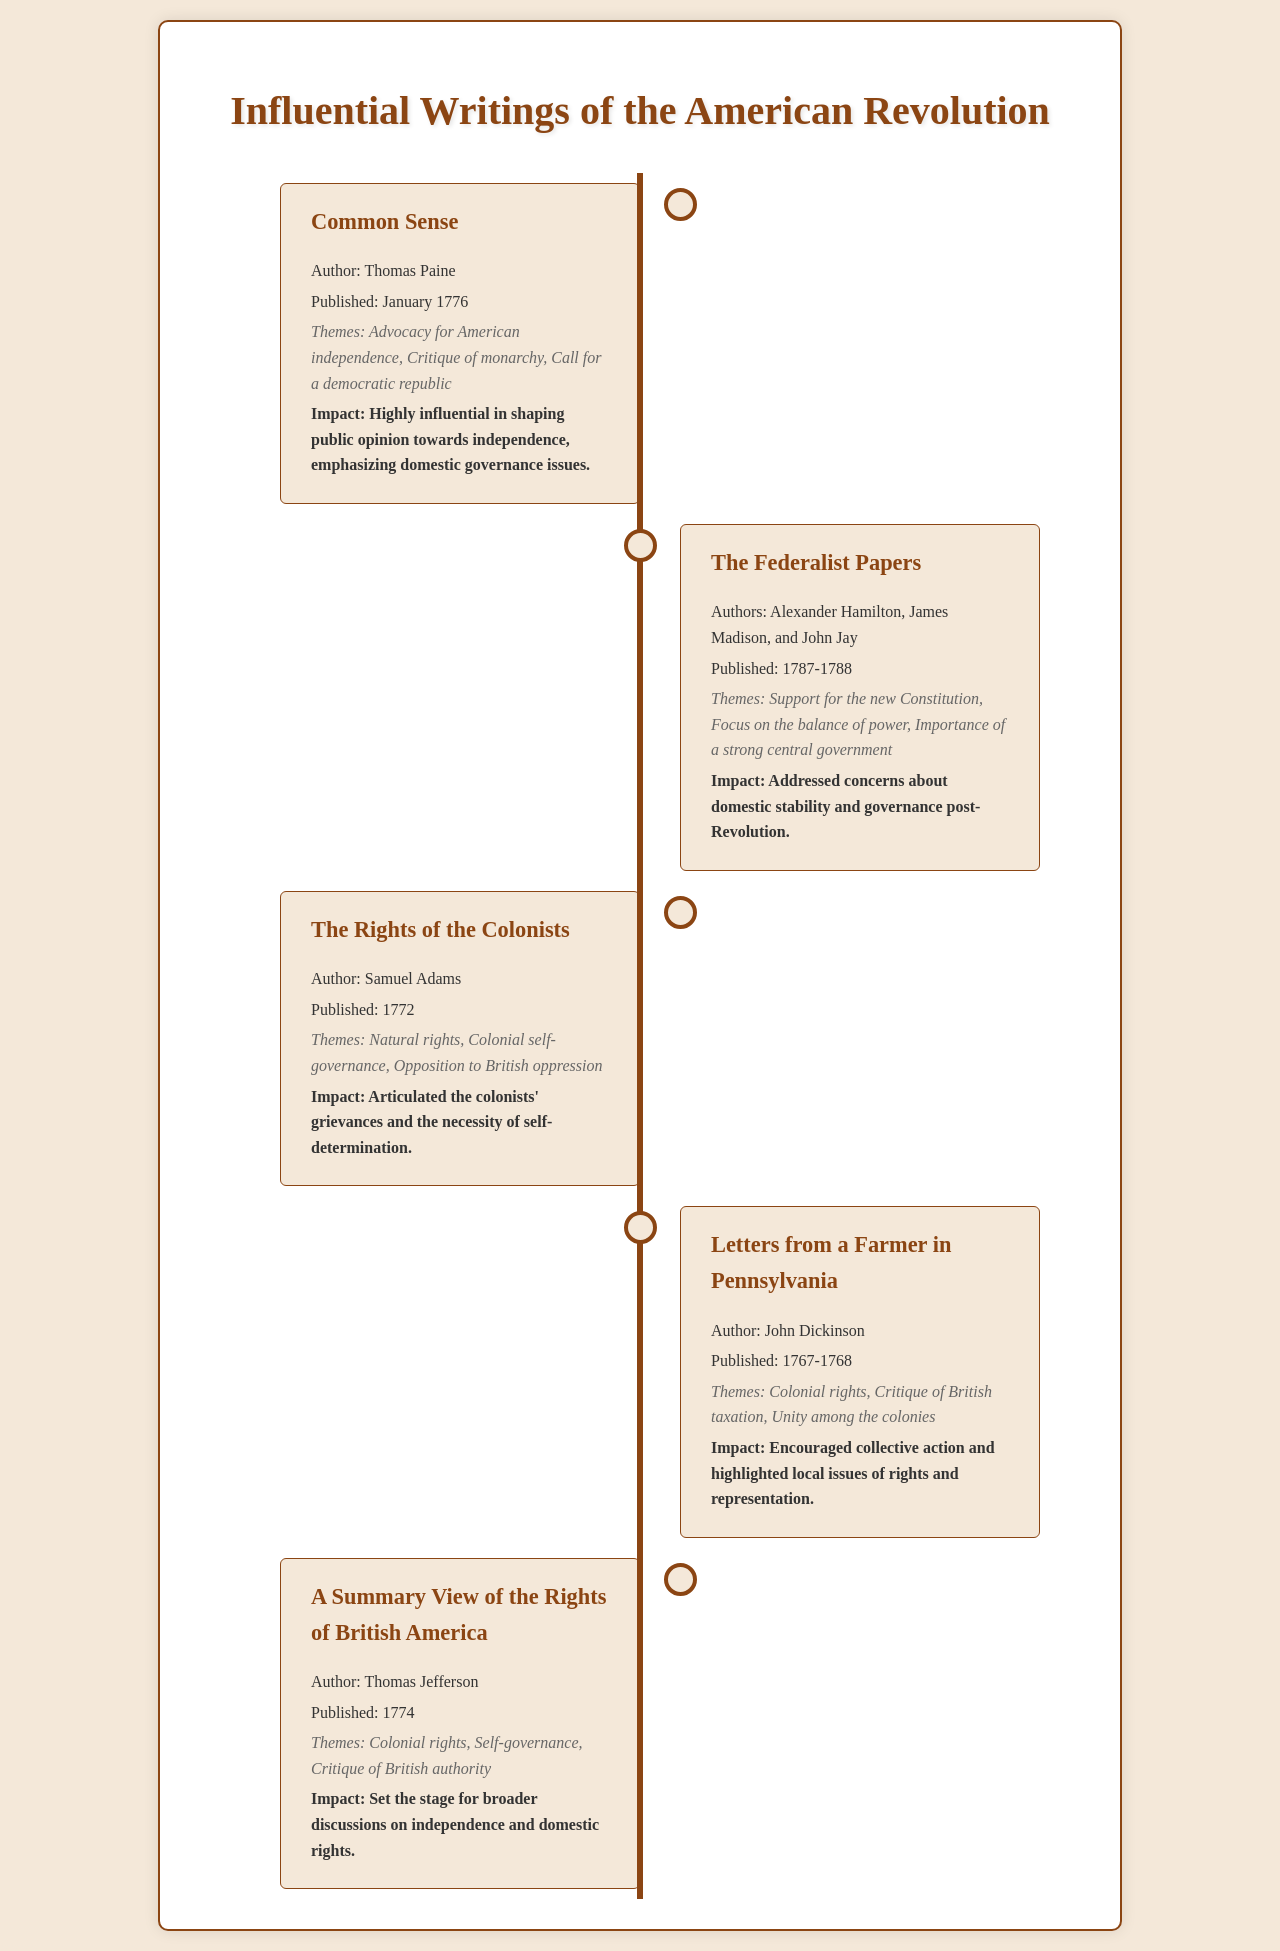What is the title of Thomas Paine's pamphlet? The document lists "Common Sense" as the title of Thomas Paine's work.
Answer: Common Sense Who authored "The Rights of the Colonists"? The author of "The Rights of the Colonists" mentioned in the document is Samuel Adams.
Answer: Samuel Adams When was "The Federalist Papers" published? The document states that "The Federalist Papers" was published between 1787 and 1788.
Answer: 1787-1788 What theme is highlighted in "Letters from a Farmer in Pennsylvania"? The document specifies the theme as "Colonial rights" for this pamphlet.
Answer: Colonial rights Which pamphlet discusses the critique of British authority? The document indicates that "A Summary View of the Rights of British America" discusses this theme.
Answer: A Summary View of the Rights of British America What impact did "Common Sense" have? The document states that "Common Sense" was highly influential in shaping public opinion towards independence.
Answer: Highly influential What year was "The Rights of the Colonists" published? According to the document, "The Rights of the Colonists" was published in 1772.
Answer: 1772 Who were the authors of "The Federalist Papers"? The document lists Alexander Hamilton, James Madison, and John Jay as the authors.
Answer: Alexander Hamilton, James Madison, and John Jay What primary issue does John Dickinson's writing address? The document highlights "Critique of British taxation" as a primary issue in his pamphlet.
Answer: Critique of British taxation 